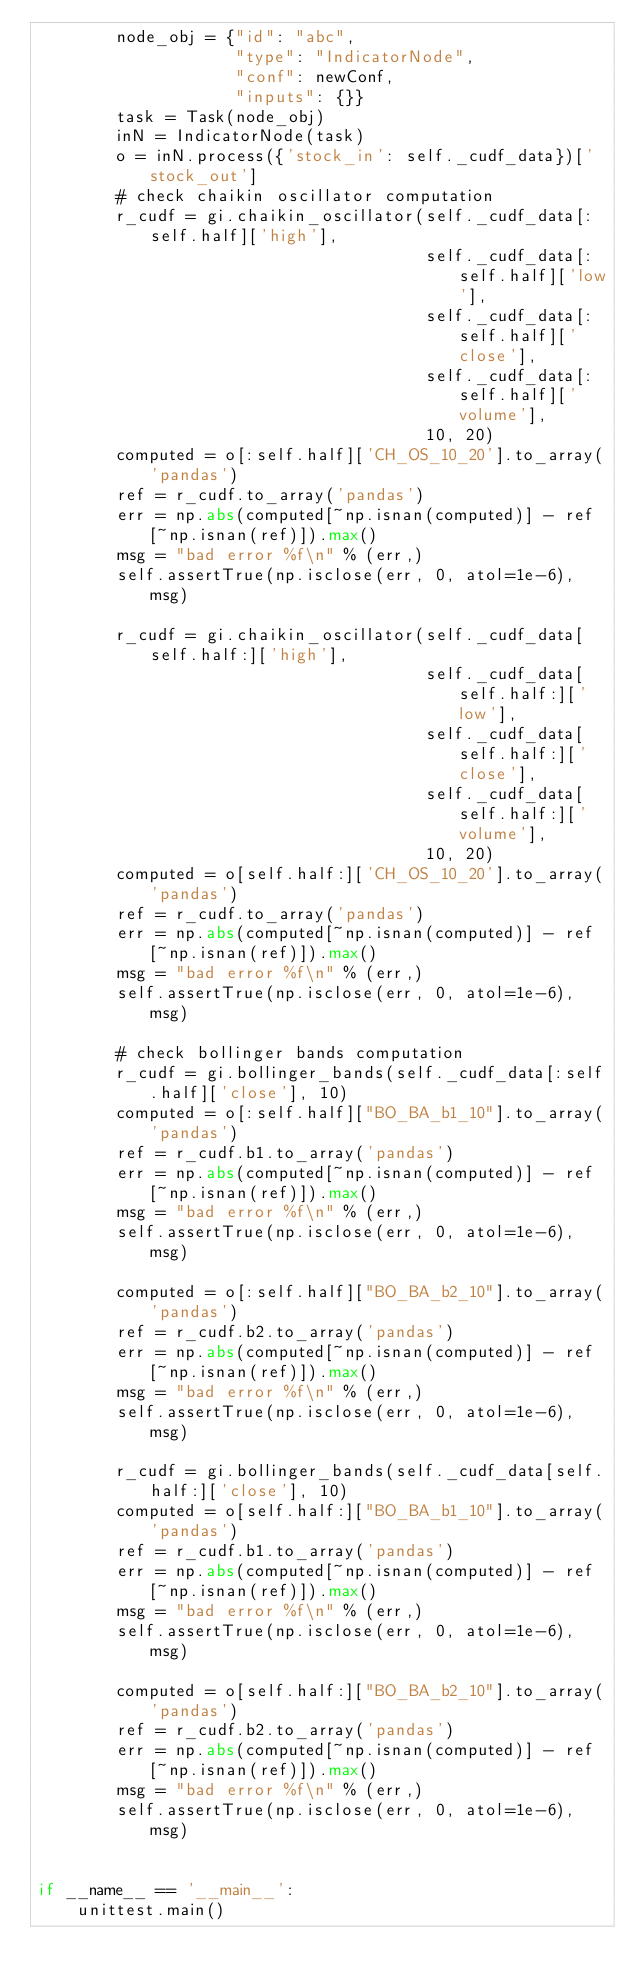<code> <loc_0><loc_0><loc_500><loc_500><_Python_>        node_obj = {"id": "abc",
                    "type": "IndicatorNode",
                    "conf": newConf,
                    "inputs": {}}
        task = Task(node_obj)
        inN = IndicatorNode(task)
        o = inN.process({'stock_in': self._cudf_data})['stock_out']
        # check chaikin oscillator computation
        r_cudf = gi.chaikin_oscillator(self._cudf_data[:self.half]['high'],
                                       self._cudf_data[:self.half]['low'],
                                       self._cudf_data[:self.half]['close'],
                                       self._cudf_data[:self.half]['volume'],
                                       10, 20)
        computed = o[:self.half]['CH_OS_10_20'].to_array('pandas')
        ref = r_cudf.to_array('pandas')
        err = np.abs(computed[~np.isnan(computed)] - ref[~np.isnan(ref)]).max()
        msg = "bad error %f\n" % (err,)
        self.assertTrue(np.isclose(err, 0, atol=1e-6), msg)

        r_cudf = gi.chaikin_oscillator(self._cudf_data[self.half:]['high'],
                                       self._cudf_data[self.half:]['low'],
                                       self._cudf_data[self.half:]['close'],
                                       self._cudf_data[self.half:]['volume'],
                                       10, 20)
        computed = o[self.half:]['CH_OS_10_20'].to_array('pandas')
        ref = r_cudf.to_array('pandas')
        err = np.abs(computed[~np.isnan(computed)] - ref[~np.isnan(ref)]).max()
        msg = "bad error %f\n" % (err,)
        self.assertTrue(np.isclose(err, 0, atol=1e-6), msg)

        # check bollinger bands computation
        r_cudf = gi.bollinger_bands(self._cudf_data[:self.half]['close'], 10)
        computed = o[:self.half]["BO_BA_b1_10"].to_array('pandas')
        ref = r_cudf.b1.to_array('pandas')
        err = np.abs(computed[~np.isnan(computed)] - ref[~np.isnan(ref)]).max()
        msg = "bad error %f\n" % (err,)
        self.assertTrue(np.isclose(err, 0, atol=1e-6), msg)

        computed = o[:self.half]["BO_BA_b2_10"].to_array('pandas')
        ref = r_cudf.b2.to_array('pandas')
        err = np.abs(computed[~np.isnan(computed)] - ref[~np.isnan(ref)]).max()
        msg = "bad error %f\n" % (err,)
        self.assertTrue(np.isclose(err, 0, atol=1e-6), msg)

        r_cudf = gi.bollinger_bands(self._cudf_data[self.half:]['close'], 10)
        computed = o[self.half:]["BO_BA_b1_10"].to_array('pandas')
        ref = r_cudf.b1.to_array('pandas')
        err = np.abs(computed[~np.isnan(computed)] - ref[~np.isnan(ref)]).max()
        msg = "bad error %f\n" % (err,)
        self.assertTrue(np.isclose(err, 0, atol=1e-6), msg)

        computed = o[self.half:]["BO_BA_b2_10"].to_array('pandas')
        ref = r_cudf.b2.to_array('pandas')
        err = np.abs(computed[~np.isnan(computed)] - ref[~np.isnan(ref)]).max()
        msg = "bad error %f\n" % (err,)
        self.assertTrue(np.isclose(err, 0, atol=1e-6), msg)


if __name__ == '__main__':
    unittest.main()
</code> 